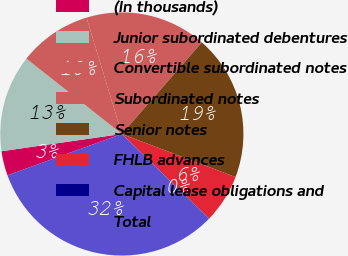Convert chart to OTSL. <chart><loc_0><loc_0><loc_500><loc_500><pie_chart><fcel>(In thousands)<fcel>Junior subordinated debentures<fcel>Convertible subordinated notes<fcel>Subordinated notes<fcel>Senior notes<fcel>FHLB advances<fcel>Capital lease obligations and<fcel>Total<nl><fcel>3.25%<fcel>12.9%<fcel>9.68%<fcel>16.12%<fcel>19.34%<fcel>6.47%<fcel>0.03%<fcel>32.21%<nl></chart> 